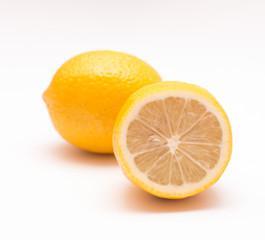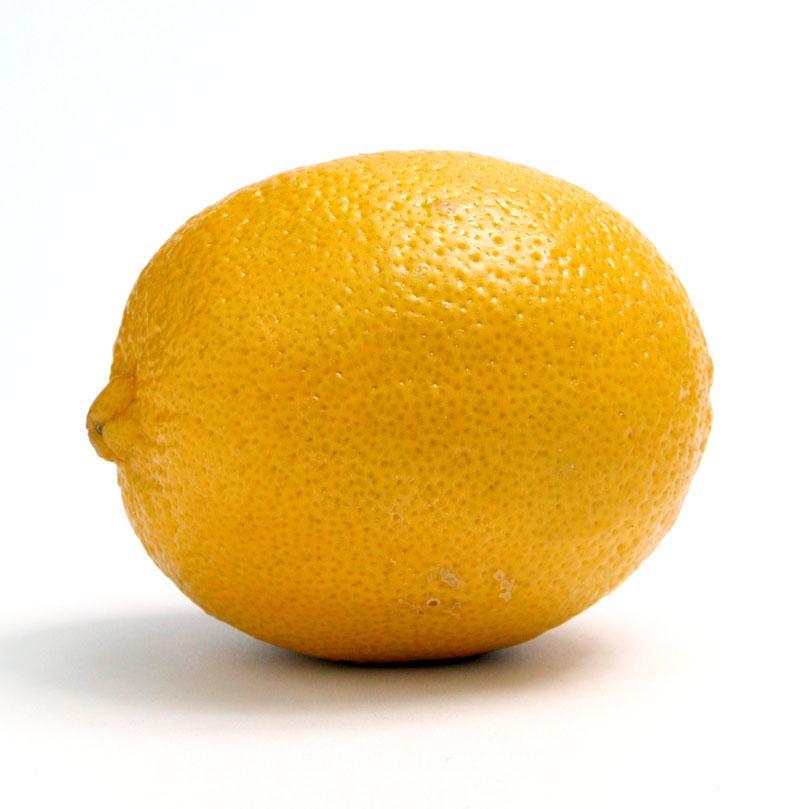The first image is the image on the left, the second image is the image on the right. Assess this claim about the two images: "The left image contain only two whole lemons.". Correct or not? Answer yes or no. No. 